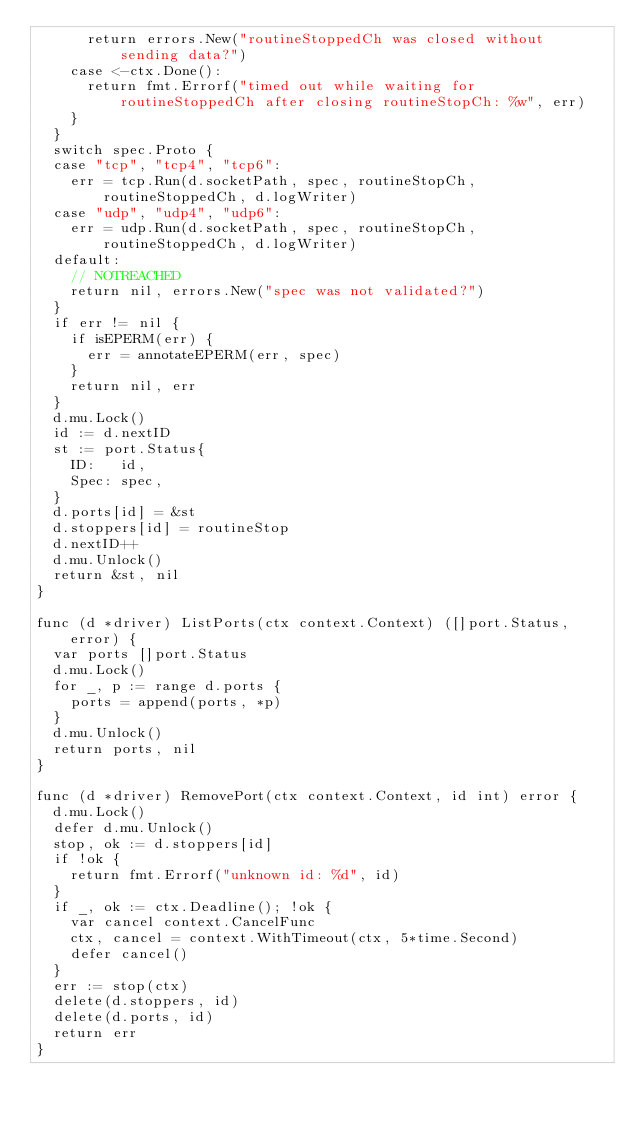Convert code to text. <code><loc_0><loc_0><loc_500><loc_500><_Go_>			return errors.New("routineStoppedCh was closed without sending data?")
		case <-ctx.Done():
			return fmt.Errorf("timed out while waiting for routineStoppedCh after closing routineStopCh: %w", err)
		}
	}
	switch spec.Proto {
	case "tcp", "tcp4", "tcp6":
		err = tcp.Run(d.socketPath, spec, routineStopCh, routineStoppedCh, d.logWriter)
	case "udp", "udp4", "udp6":
		err = udp.Run(d.socketPath, spec, routineStopCh, routineStoppedCh, d.logWriter)
	default:
		// NOTREACHED
		return nil, errors.New("spec was not validated?")
	}
	if err != nil {
		if isEPERM(err) {
			err = annotateEPERM(err, spec)
		}
		return nil, err
	}
	d.mu.Lock()
	id := d.nextID
	st := port.Status{
		ID:   id,
		Spec: spec,
	}
	d.ports[id] = &st
	d.stoppers[id] = routineStop
	d.nextID++
	d.mu.Unlock()
	return &st, nil
}

func (d *driver) ListPorts(ctx context.Context) ([]port.Status, error) {
	var ports []port.Status
	d.mu.Lock()
	for _, p := range d.ports {
		ports = append(ports, *p)
	}
	d.mu.Unlock()
	return ports, nil
}

func (d *driver) RemovePort(ctx context.Context, id int) error {
	d.mu.Lock()
	defer d.mu.Unlock()
	stop, ok := d.stoppers[id]
	if !ok {
		return fmt.Errorf("unknown id: %d", id)
	}
	if _, ok := ctx.Deadline(); !ok {
		var cancel context.CancelFunc
		ctx, cancel = context.WithTimeout(ctx, 5*time.Second)
		defer cancel()
	}
	err := stop(ctx)
	delete(d.stoppers, id)
	delete(d.ports, id)
	return err
}
</code> 